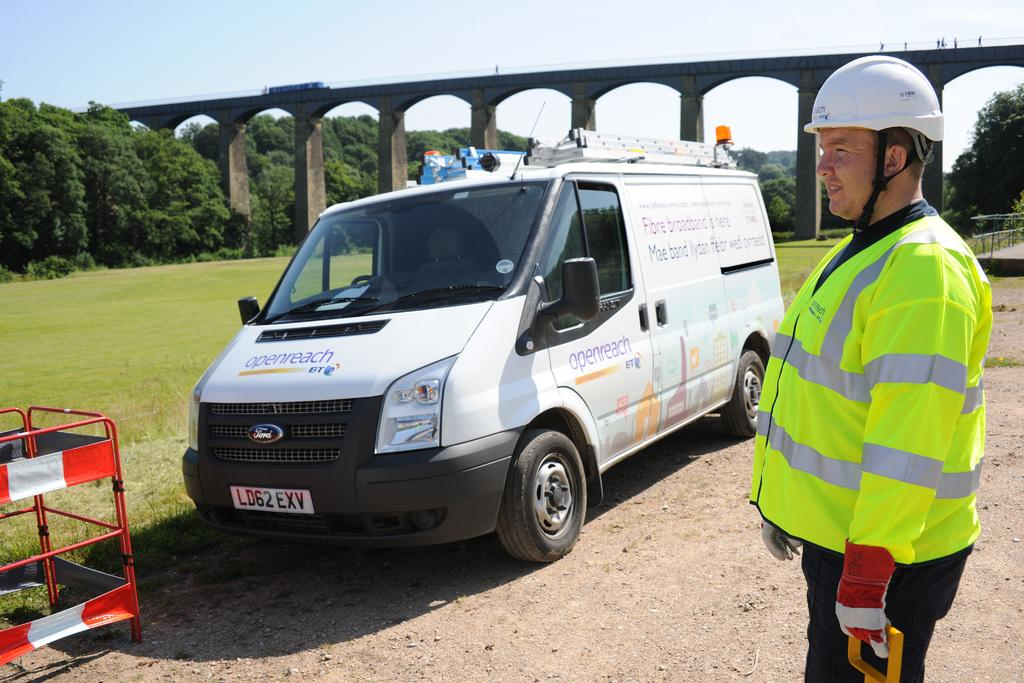<image>
Write a terse but informative summary of the picture. Openreach van that says BT on the front of the hood with a Man in a crossing guard uniform. 